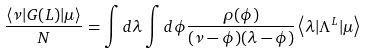Convert formula to latex. <formula><loc_0><loc_0><loc_500><loc_500>\frac { \left \langle \nu | G ( L ) | \mu \right \rangle } { N } = \int d \lambda \int d \phi \frac { \rho ( \phi ) } { ( \nu - \phi ) ( \lambda - \phi ) } \left \langle \lambda | \Lambda ^ { L } | \mu \right \rangle</formula> 